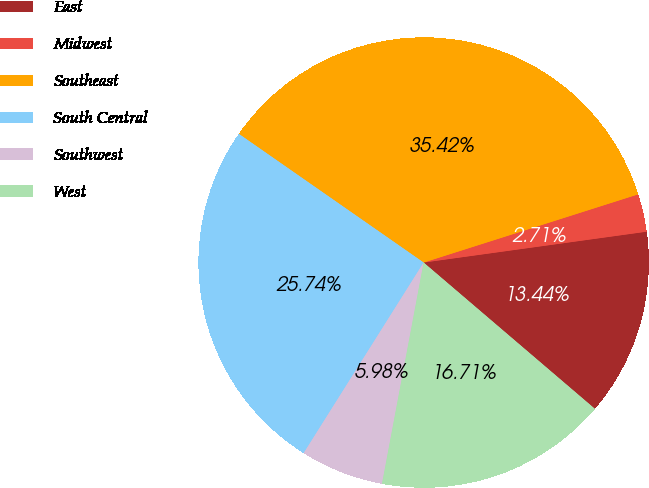Convert chart. <chart><loc_0><loc_0><loc_500><loc_500><pie_chart><fcel>East<fcel>Midwest<fcel>Southeast<fcel>South Central<fcel>Southwest<fcel>West<nl><fcel>13.44%<fcel>2.71%<fcel>35.42%<fcel>25.74%<fcel>5.98%<fcel>16.71%<nl></chart> 